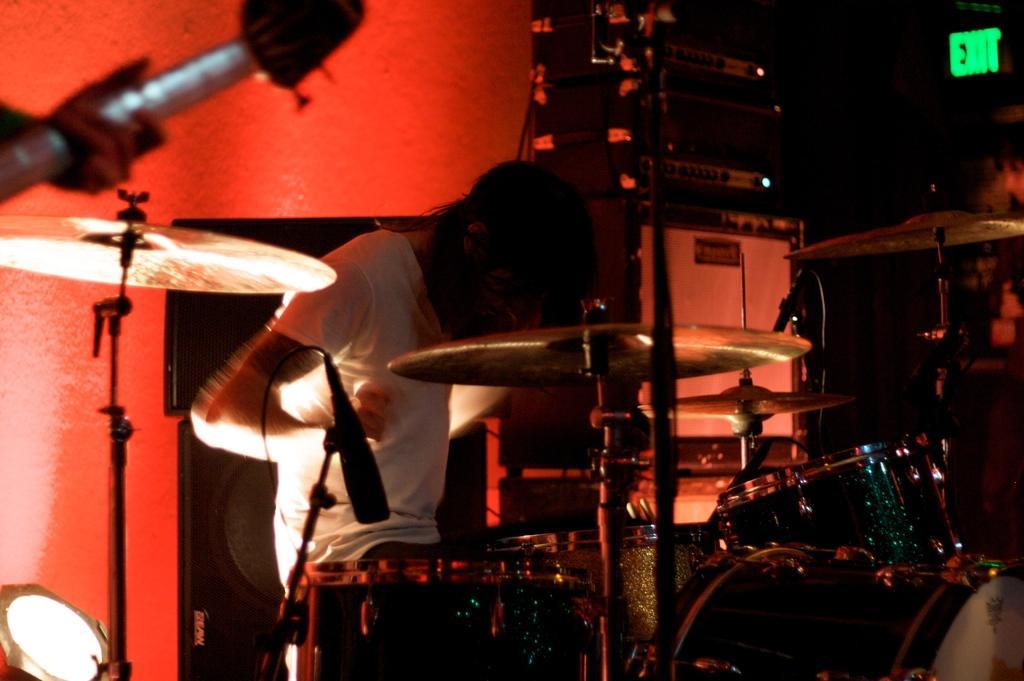Can you describe this image briefly? There is one person standing and wearing a white color t shirt is playing drums as we can see in the middle of this image. There is a human hand holding a guitar at the top left side of this image, and there is a wall in the background. 